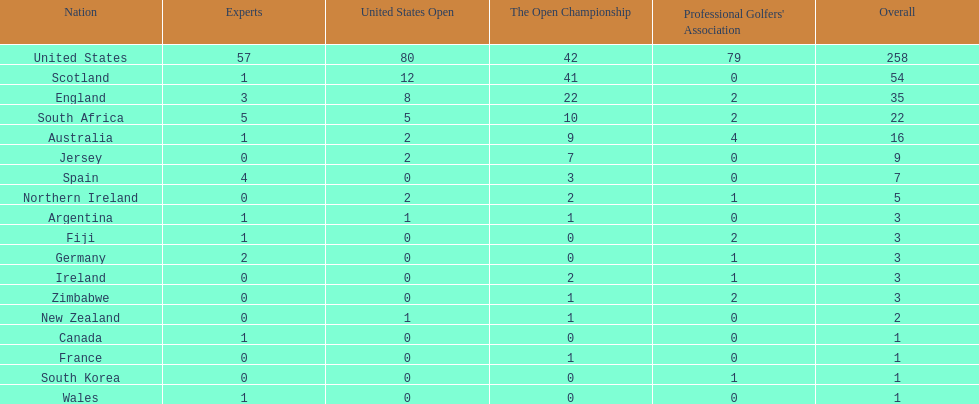Parse the table in full. {'header': ['Nation', 'Experts', 'United States Open', 'The Open Championship', "Professional Golfers' Association", 'Overall'], 'rows': [['United States', '57', '80', '42', '79', '258'], ['Scotland', '1', '12', '41', '0', '54'], ['England', '3', '8', '22', '2', '35'], ['South Africa', '5', '5', '10', '2', '22'], ['Australia', '1', '2', '9', '4', '16'], ['Jersey', '0', '2', '7', '0', '9'], ['Spain', '4', '0', '3', '0', '7'], ['Northern Ireland', '0', '2', '2', '1', '5'], ['Argentina', '1', '1', '1', '0', '3'], ['Fiji', '1', '0', '0', '2', '3'], ['Germany', '2', '0', '0', '1', '3'], ['Ireland', '0', '0', '2', '1', '3'], ['Zimbabwe', '0', '0', '1', '2', '3'], ['New Zealand', '0', '1', '1', '0', '2'], ['Canada', '1', '0', '0', '0', '1'], ['France', '0', '0', '1', '0', '1'], ['South Korea', '0', '0', '0', '1', '1'], ['Wales', '1', '0', '0', '0', '1']]} How many nations have generated an equal amount of championship golfers as canada? 3. 